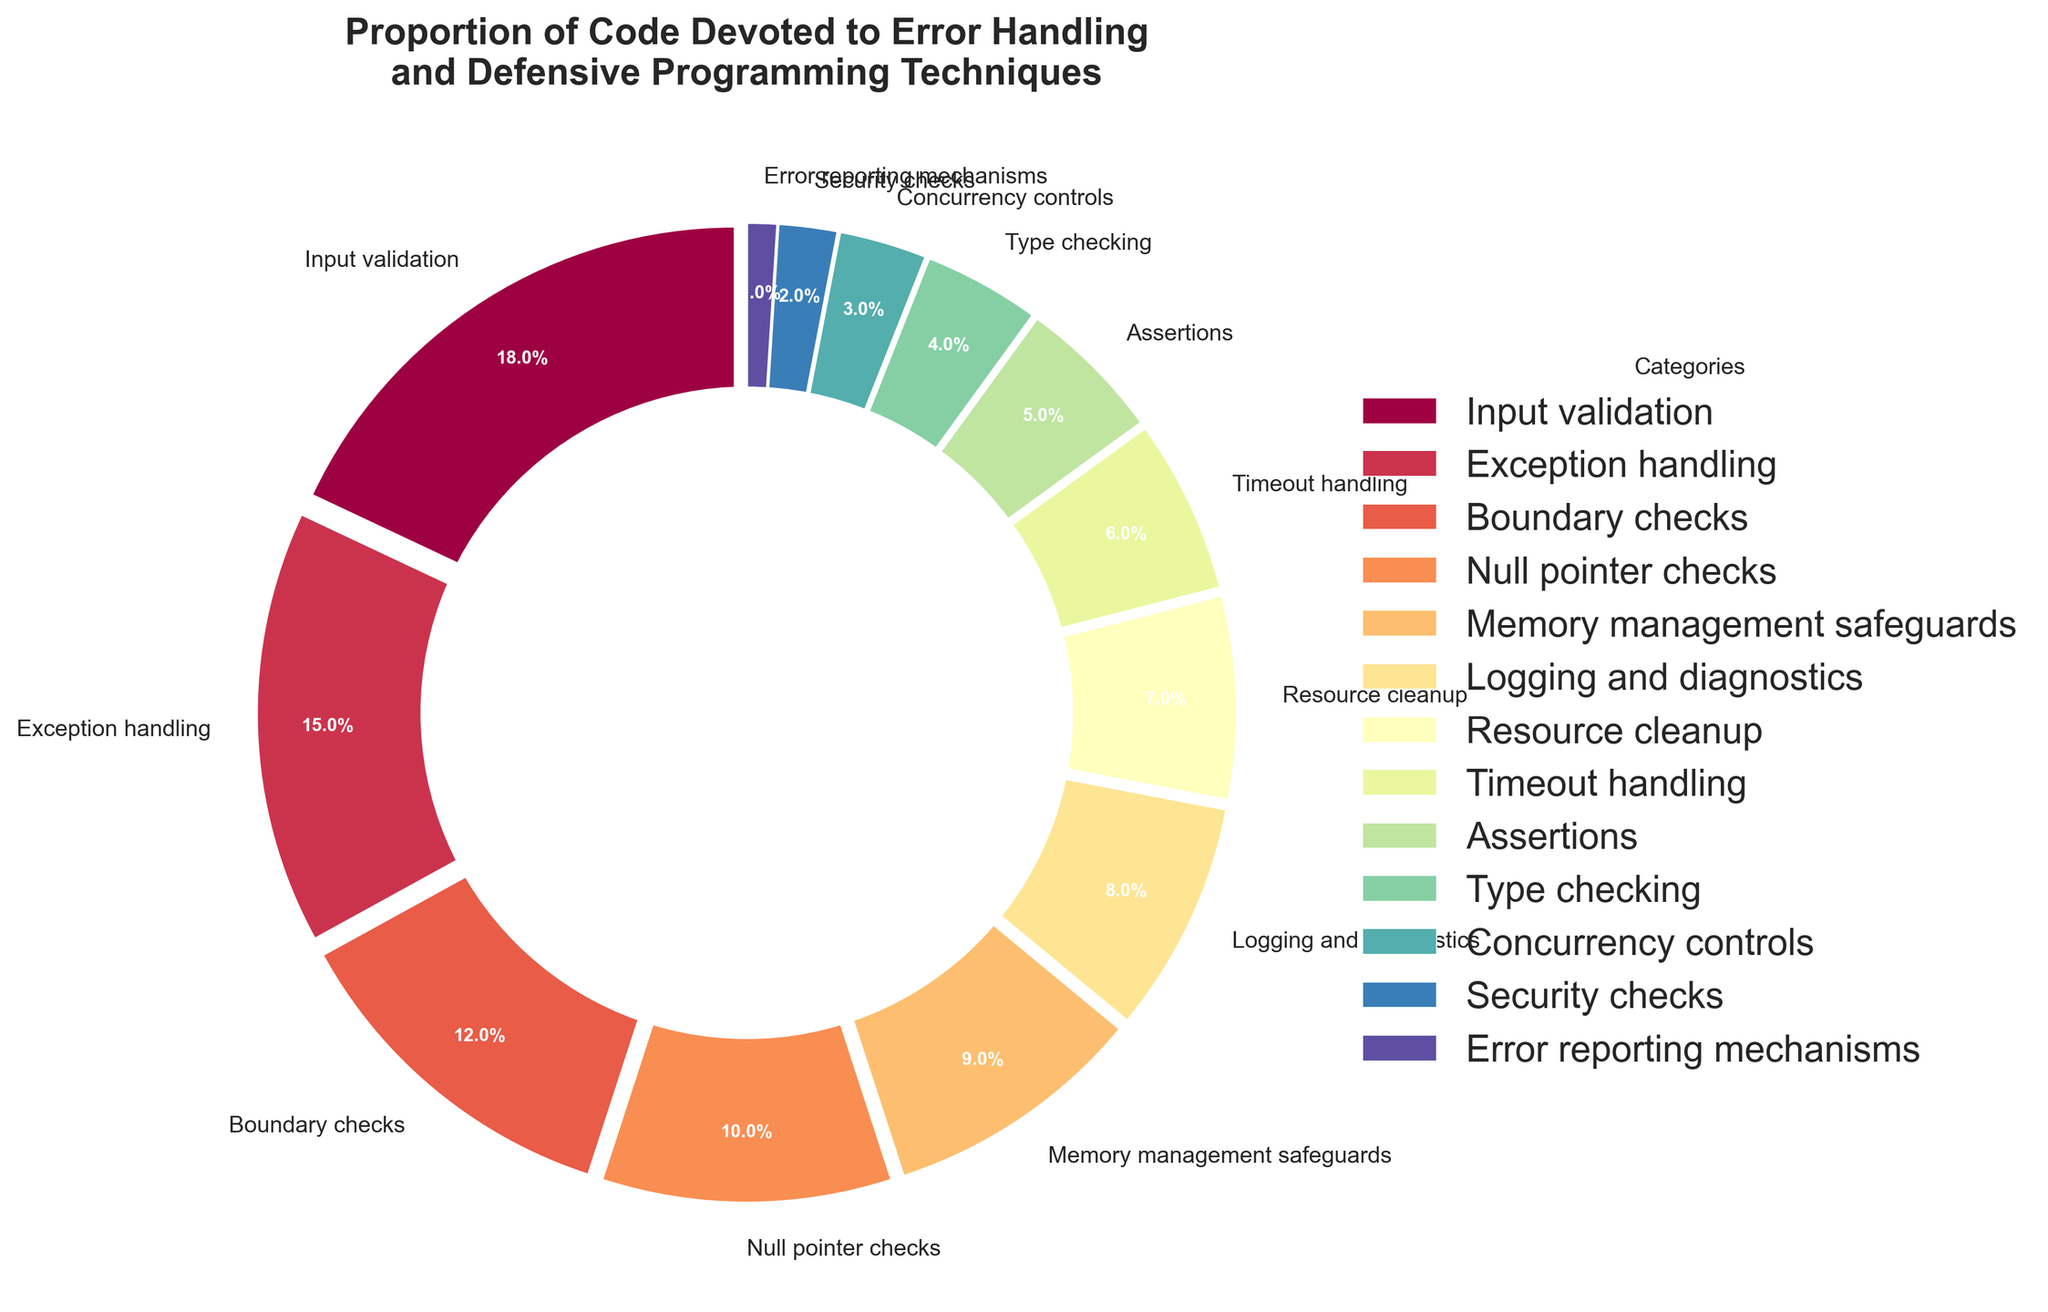What is the total percentage of code devoted to Input validation, Exception handling, and Boundary checks combined? To find the total percentage of code devoted to these three categories, simply sum their respective percentages: 18% (Input validation) + 15% (Exception handling) + 12% (Boundary checks). The total is 18 + 15 + 12 = 45.
Answer: 45% Which category has the largest proportion of code devoted to it? By visually inspecting the pie chart, the wedge with the largest area will correspond to the category with the largest proportion. Here, Input validation has the largest slice, which is 18%.
Answer: Input validation Which category has a smaller proportion of code devoted to it: Logging and diagnostics or Type checking? By comparing the two categories, Logging and diagnostics is 8%, and Type checking is 4%. Since 4% is less than 8%, Type checking has a smaller proportion.
Answer: Type checking What is the difference in the proportion of code devoted to Resource cleanup and Concurrency controls? To find the difference, subtract the percentage of code for Concurrency controls (3%) from that for Resource cleanup (7%). So, the difference is 7 - 3 = 4.
Answer: 4% What percentage of code is devoted to both Memory management safeguards and Timeout handling combined? Adding the percentages of Memory management safeguards (9%) and Timeout handling (6%), we get a combined total of 9 + 6 = 15.
Answer: 15% Which has a higher percentage of code devoted to it, Assertions or Boundary checks? Checking the percentages, Assertions have 5%, and Boundary checks have 12%. Since 12% is greater than 5%, Boundary checks have a higher percentage.
Answer: Boundary checks How many categories have a proportion of code devoted to them that is less than 10%? From the pie chart, the categories with less than 10% are Memory management safeguards (9%), Logging and diagnostics (8%), Resource cleanup (7%), Timeout handling (6%), Assertions (5%), Type checking (4%), Concurrency controls (3%), Security checks (2%), and Error reporting mechanisms (1%). Counting these, there are 9 categories.
Answer: 9 categories What is the average percentage of code devoted to Security checks and Error reporting mechanisms? To find the average, add the two percentages and then divide by 2: (2% + 1%) / 2 = 3 / 2 = 1.5.
Answer: 1.5% Estimate the color transition for Timeout handling and provide its visual location in the pie chart. Timeout handling has 6% and is represented by a moderately small wedge towards the top right near the start angle of 90 degrees. The colors in the pie chart transition smoothly around the spectrum, with Timeout handling likely being in the lighter spectrum of the color map.
Answer: Top right, light spectrum 